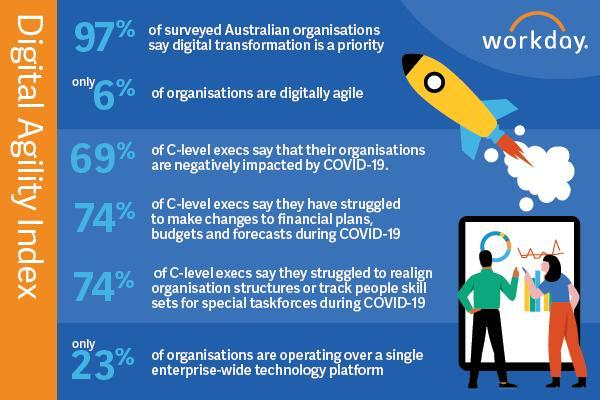What is the measurement about?
Answer the question with a short phrase. Digital Agility Index To what percent of organizations is digital transformation not a priority? 3% 